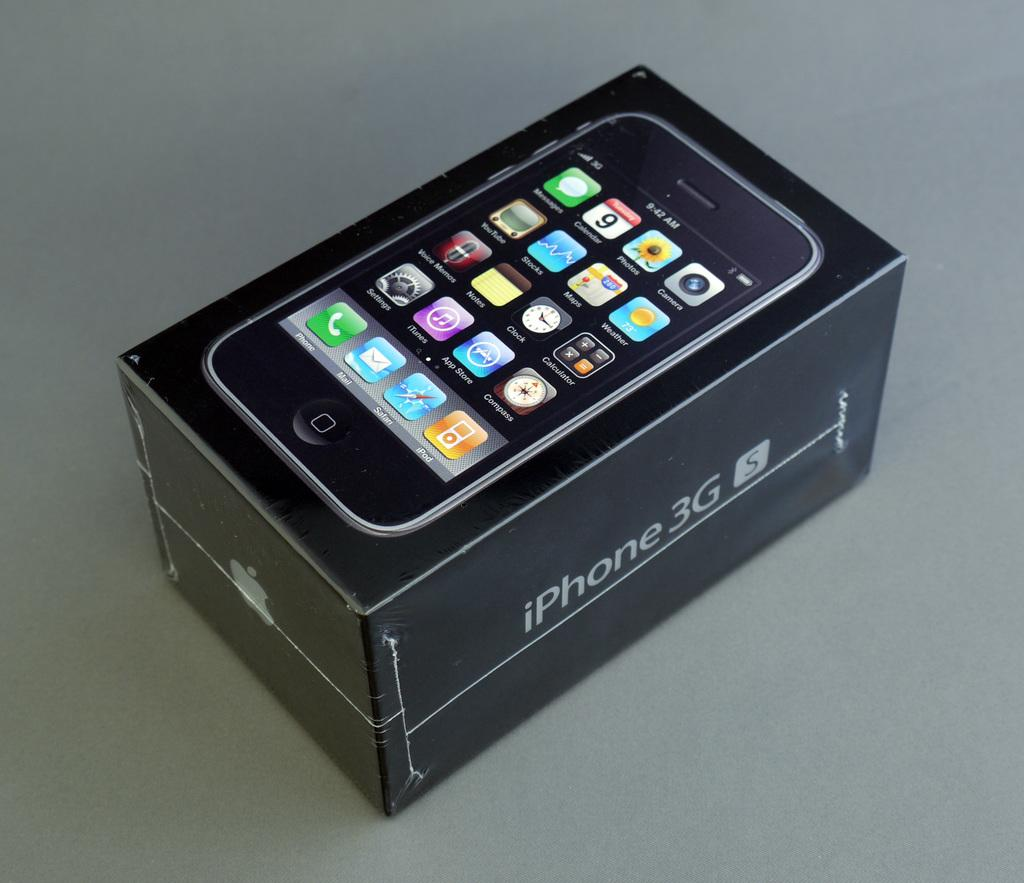<image>
Provide a brief description of the given image. an iPhone case that has 3G written on it 